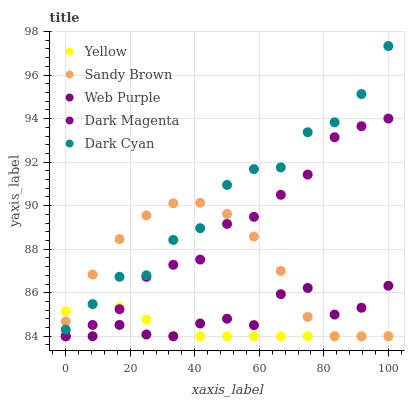Does Yellow have the minimum area under the curve?
Answer yes or no. Yes. Does Dark Cyan have the maximum area under the curve?
Answer yes or no. Yes. Does Web Purple have the minimum area under the curve?
Answer yes or no. No. Does Web Purple have the maximum area under the curve?
Answer yes or no. No. Is Yellow the smoothest?
Answer yes or no. Yes. Is Dark Cyan the roughest?
Answer yes or no. Yes. Is Web Purple the smoothest?
Answer yes or no. No. Is Web Purple the roughest?
Answer yes or no. No. Does Web Purple have the lowest value?
Answer yes or no. Yes. Does Dark Cyan have the highest value?
Answer yes or no. Yes. Does Web Purple have the highest value?
Answer yes or no. No. Is Web Purple less than Dark Cyan?
Answer yes or no. Yes. Is Dark Cyan greater than Web Purple?
Answer yes or no. Yes. Does Sandy Brown intersect Dark Magenta?
Answer yes or no. Yes. Is Sandy Brown less than Dark Magenta?
Answer yes or no. No. Is Sandy Brown greater than Dark Magenta?
Answer yes or no. No. Does Web Purple intersect Dark Cyan?
Answer yes or no. No. 